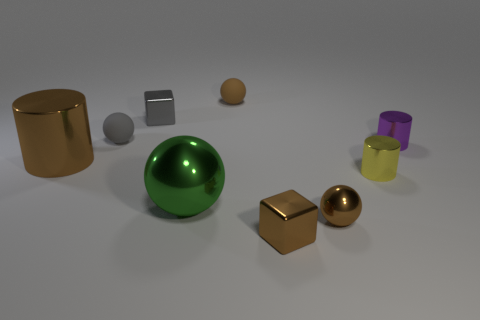There is a cube that is behind the big metallic cylinder; what size is it?
Your answer should be compact. Small. Are there fewer large brown cylinders in front of the big brown metallic cylinder than brown matte things that are on the right side of the small purple metal thing?
Offer a terse response. No. What is the material of the sphere that is both left of the brown rubber object and in front of the gray rubber sphere?
Make the answer very short. Metal. The large object that is right of the metal object that is behind the small gray sphere is what shape?
Keep it short and to the point. Sphere. Does the big metal cylinder have the same color as the big metallic ball?
Your answer should be compact. No. How many blue things are small metal cylinders or shiny cylinders?
Offer a terse response. 0. Are there any matte spheres left of the tiny brown rubber object?
Your answer should be very brief. Yes. What is the size of the yellow cylinder?
Give a very brief answer. Small. What is the size of the brown metal object that is the same shape as the gray metal object?
Keep it short and to the point. Small. There is a small metal block that is in front of the small yellow thing; what number of large brown things are in front of it?
Give a very brief answer. 0. 